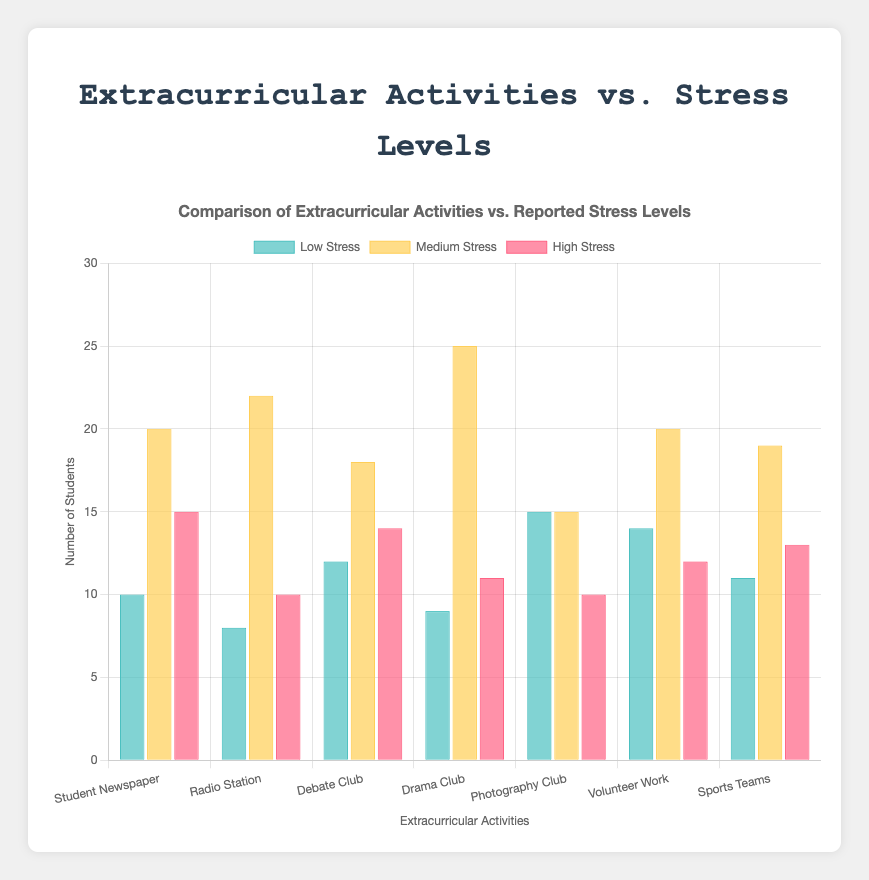Which extracurricular activity has the most students experiencing medium stress? Drama Club has the most medium stress students with a count of 25. This can be determined by looking for the tallest yellow bar among the medium stress categories.
Answer: Drama Club Which activity has the highest number of low-stress students? Photography Club has the highest number of low-stress students with a count of 15. This is visible by identifying the activity with the tallest green bar in the low-stress category.
Answer: Photography Club What is the total number of students participating in Volunteer Work? Summing the stress categories (low, medium, high) for Volunteer Work gives 14 + 20 + 12 = 46.
Answer: 46 Compare the number of high-stress students between Radio Station and Debate Club. Which one has more, and by how much? Debate Club has 14 high-stress students, and Radio Station has 10. The difference is 14 - 10 = 4, hence Debate Club has 4 more high-stress students.
Answer: Debate Club by 4 Which two activities have an equal number of medium-stress students, and what is the count? Student Newspaper and Volunteer Work both have 20 medium-stress students. This can be seen by comparing the heights of the yellow bars for these activities, which are the same.
Answer: Student Newspaper and Volunteer Work, 20 For Student Newspaper, how many more students report medium stress compared to low stress? The number of students reporting medium stress is 20, and for low stress, it is 10. The difference is 20 - 10 = 10.
Answer: 10 What is the average number of high-stress students across all activities? Adding up the high-stress students (15 + 10 + 14 + 11 + 10 + 12 + 13) gives 85. There are 7 activities, so the average is 85 / 7 ≈ 12.14.
Answer: Approximately 12.14 Which activity has the least overall students involved when combining all stress levels? Radio Station has total students of 8 (low) + 22 (medium) + 10 (high) = 40. This is the lowest total compared to other activities.
Answer: Radio Station How many activities have more than 10 students reporting low stress? Activities with more than 10 students reporting low stress are Debate Club (12), Photography Club (15), Volunteer Work (14), and Sports Teams (11). There are 4 such activities.
Answer: 4 